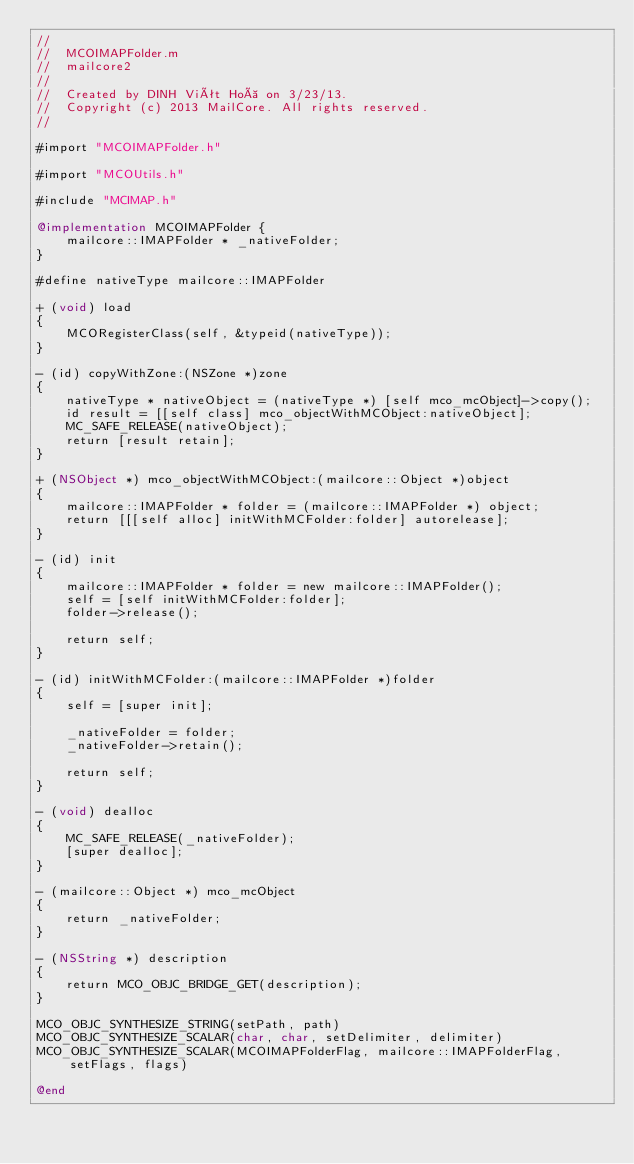<code> <loc_0><loc_0><loc_500><loc_500><_ObjectiveC_>//
//  MCOIMAPFolder.m
//  mailcore2
//
//  Created by DINH Viêt Hoà on 3/23/13.
//  Copyright (c) 2013 MailCore. All rights reserved.
//

#import "MCOIMAPFolder.h"

#import "MCOUtils.h"

#include "MCIMAP.h"

@implementation MCOIMAPFolder {
    mailcore::IMAPFolder * _nativeFolder;
}

#define nativeType mailcore::IMAPFolder

+ (void) load
{
    MCORegisterClass(self, &typeid(nativeType));
}

- (id) copyWithZone:(NSZone *)zone
{
    nativeType * nativeObject = (nativeType *) [self mco_mcObject]->copy();
    id result = [[self class] mco_objectWithMCObject:nativeObject];
    MC_SAFE_RELEASE(nativeObject);
    return [result retain];
}

+ (NSObject *) mco_objectWithMCObject:(mailcore::Object *)object
{
    mailcore::IMAPFolder * folder = (mailcore::IMAPFolder *) object;
    return [[[self alloc] initWithMCFolder:folder] autorelease];
}

- (id) init
{
    mailcore::IMAPFolder * folder = new mailcore::IMAPFolder();
    self = [self initWithMCFolder:folder];
    folder->release();
    
    return self;
}

- (id) initWithMCFolder:(mailcore::IMAPFolder *)folder
{
    self = [super init];
    
    _nativeFolder = folder;
    _nativeFolder->retain();
    
    return self;
}

- (void) dealloc
{
    MC_SAFE_RELEASE(_nativeFolder);
    [super dealloc];
}

- (mailcore::Object *) mco_mcObject
{
    return _nativeFolder;
}

- (NSString *) description
{
    return MCO_OBJC_BRIDGE_GET(description);
}

MCO_OBJC_SYNTHESIZE_STRING(setPath, path)
MCO_OBJC_SYNTHESIZE_SCALAR(char, char, setDelimiter, delimiter)
MCO_OBJC_SYNTHESIZE_SCALAR(MCOIMAPFolderFlag, mailcore::IMAPFolderFlag, setFlags, flags)

@end
</code> 